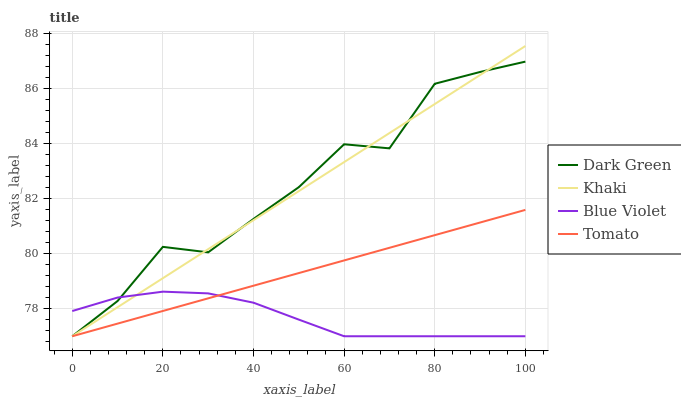Does Blue Violet have the minimum area under the curve?
Answer yes or no. Yes. Does Dark Green have the maximum area under the curve?
Answer yes or no. Yes. Does Khaki have the minimum area under the curve?
Answer yes or no. No. Does Khaki have the maximum area under the curve?
Answer yes or no. No. Is Khaki the smoothest?
Answer yes or no. Yes. Is Dark Green the roughest?
Answer yes or no. Yes. Is Blue Violet the smoothest?
Answer yes or no. No. Is Blue Violet the roughest?
Answer yes or no. No. Does Tomato have the lowest value?
Answer yes or no. Yes. Does Khaki have the highest value?
Answer yes or no. Yes. Does Blue Violet have the highest value?
Answer yes or no. No. Does Blue Violet intersect Tomato?
Answer yes or no. Yes. Is Blue Violet less than Tomato?
Answer yes or no. No. Is Blue Violet greater than Tomato?
Answer yes or no. No. 